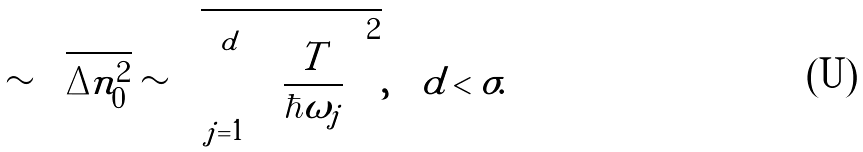<formula> <loc_0><loc_0><loc_500><loc_500>\sim \sqrt { \Delta n _ { 0 } ^ { 2 } } \sim \sqrt { \sum _ { j = 1 } ^ { d } \left ( \frac { T } { \hbar { \omega } _ { j } } \right ) ^ { 2 } } , \quad d < \sigma .</formula> 